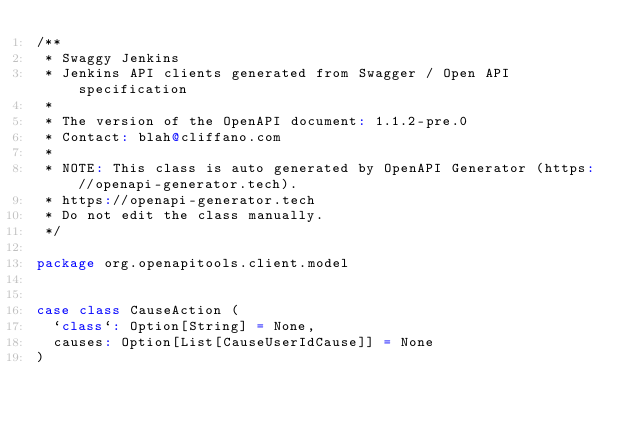Convert code to text. <code><loc_0><loc_0><loc_500><loc_500><_Scala_>/**
 * Swaggy Jenkins
 * Jenkins API clients generated from Swagger / Open API specification
 *
 * The version of the OpenAPI document: 1.1.2-pre.0
 * Contact: blah@cliffano.com
 *
 * NOTE: This class is auto generated by OpenAPI Generator (https://openapi-generator.tech).
 * https://openapi-generator.tech
 * Do not edit the class manually.
 */

package org.openapitools.client.model


case class CauseAction (
  `class`: Option[String] = None,
  causes: Option[List[CauseUserIdCause]] = None
)

</code> 